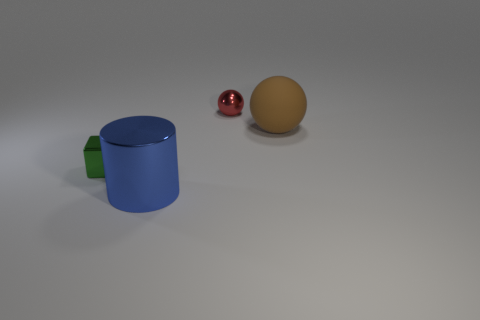Are there any other things that have the same shape as the big blue object?
Your response must be concise. No. The metallic object that is both on the right side of the tiny shiny block and in front of the big brown matte thing has what shape?
Provide a short and direct response. Cylinder. How many purple things are matte spheres or small spheres?
Offer a terse response. 0. There is a object that is on the left side of the blue cylinder; is it the same size as the ball that is behind the big brown ball?
Keep it short and to the point. Yes. How many things are brown spheres or large metallic blocks?
Offer a terse response. 1. Is there a small red matte object of the same shape as the green metallic thing?
Your response must be concise. No. Is the number of green metallic blocks less than the number of big yellow cubes?
Provide a succinct answer. No. Is the big blue thing the same shape as the green metallic object?
Keep it short and to the point. No. How many things are either small red spheres or things that are in front of the brown rubber sphere?
Make the answer very short. 3. What number of blue cubes are there?
Your response must be concise. 0. 